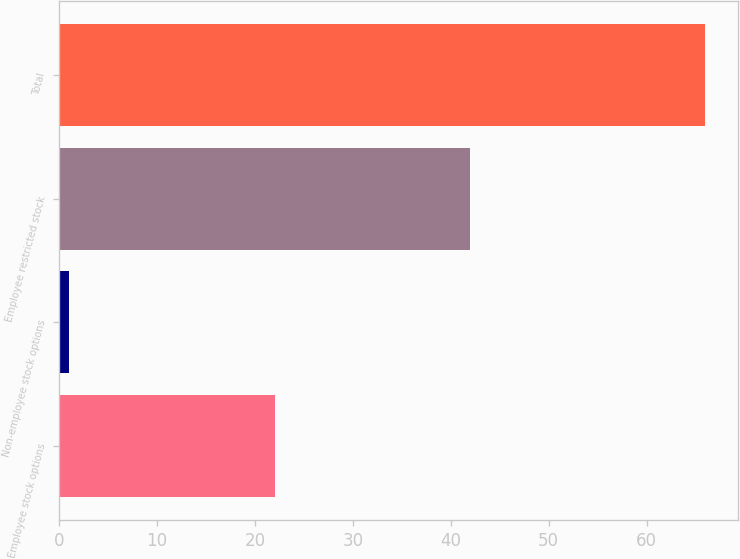<chart> <loc_0><loc_0><loc_500><loc_500><bar_chart><fcel>Employee stock options<fcel>Non-employee stock options<fcel>Employee restricted stock<fcel>Total<nl><fcel>22<fcel>1<fcel>42<fcel>66<nl></chart> 